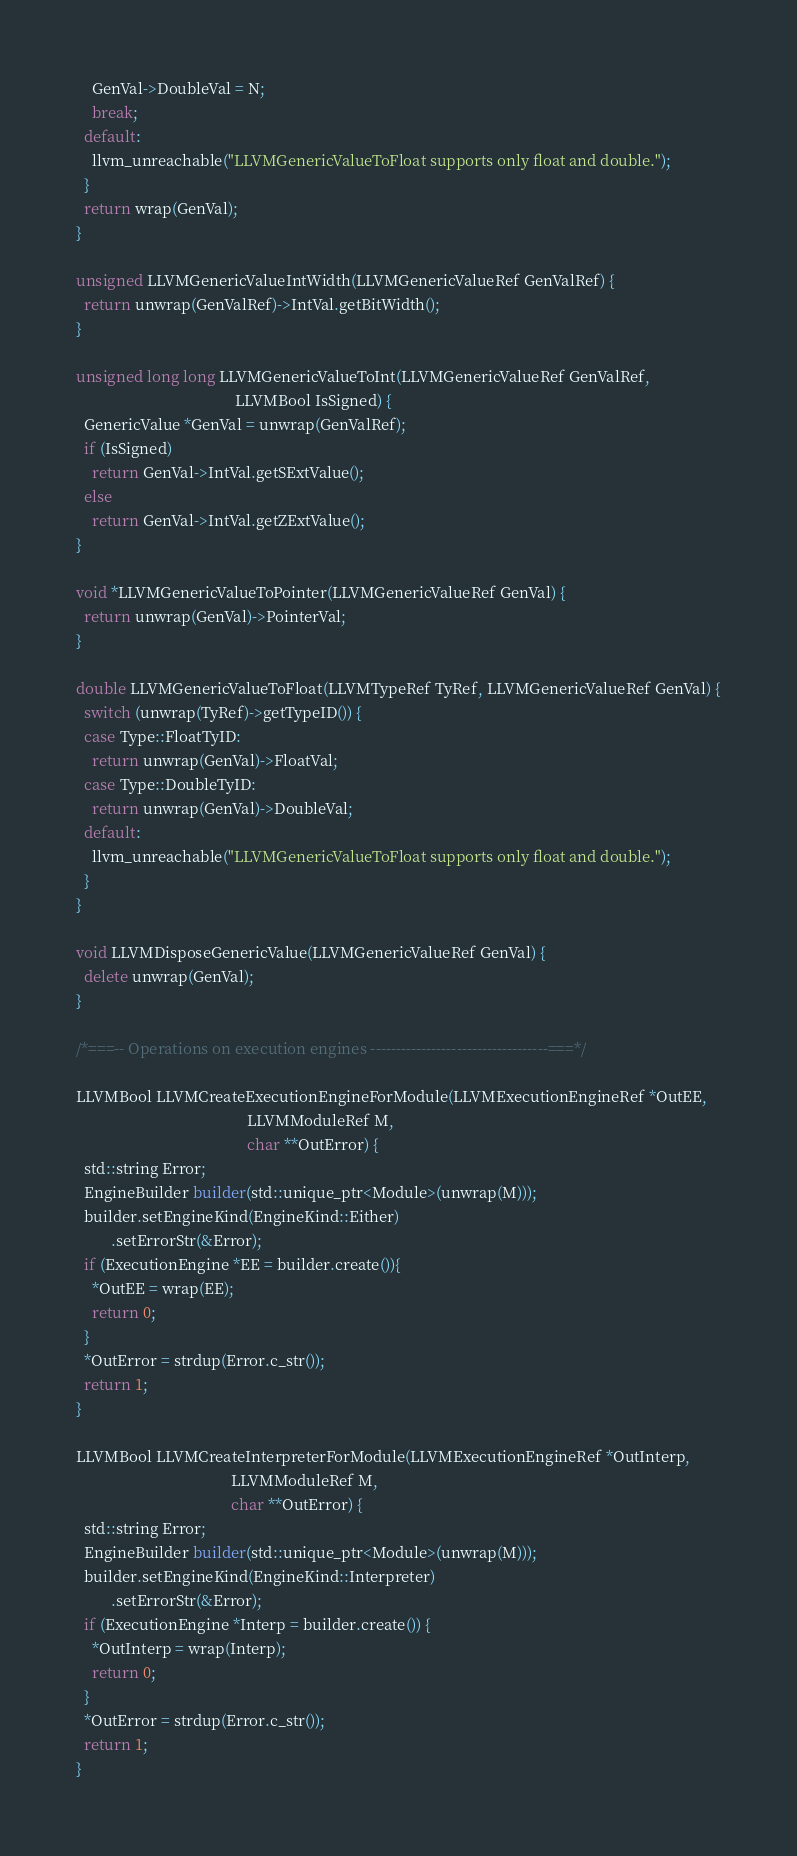<code> <loc_0><loc_0><loc_500><loc_500><_C++_>    GenVal->DoubleVal = N;
    break;
  default:
    llvm_unreachable("LLVMGenericValueToFloat supports only float and double.");
  }
  return wrap(GenVal);
}

unsigned LLVMGenericValueIntWidth(LLVMGenericValueRef GenValRef) {
  return unwrap(GenValRef)->IntVal.getBitWidth();
}

unsigned long long LLVMGenericValueToInt(LLVMGenericValueRef GenValRef,
                                         LLVMBool IsSigned) {
  GenericValue *GenVal = unwrap(GenValRef);
  if (IsSigned)
    return GenVal->IntVal.getSExtValue();
  else
    return GenVal->IntVal.getZExtValue();
}

void *LLVMGenericValueToPointer(LLVMGenericValueRef GenVal) {
  return unwrap(GenVal)->PointerVal;
}

double LLVMGenericValueToFloat(LLVMTypeRef TyRef, LLVMGenericValueRef GenVal) {
  switch (unwrap(TyRef)->getTypeID()) {
  case Type::FloatTyID:
    return unwrap(GenVal)->FloatVal;
  case Type::DoubleTyID:
    return unwrap(GenVal)->DoubleVal;
  default:
    llvm_unreachable("LLVMGenericValueToFloat supports only float and double.");
  }
}

void LLVMDisposeGenericValue(LLVMGenericValueRef GenVal) {
  delete unwrap(GenVal);
}

/*===-- Operations on execution engines -----------------------------------===*/

LLVMBool LLVMCreateExecutionEngineForModule(LLVMExecutionEngineRef *OutEE,
                                            LLVMModuleRef M,
                                            char **OutError) {
  std::string Error;
  EngineBuilder builder(std::unique_ptr<Module>(unwrap(M)));
  builder.setEngineKind(EngineKind::Either)
         .setErrorStr(&Error);
  if (ExecutionEngine *EE = builder.create()){
    *OutEE = wrap(EE);
    return 0;
  }
  *OutError = strdup(Error.c_str());
  return 1;
}

LLVMBool LLVMCreateInterpreterForModule(LLVMExecutionEngineRef *OutInterp,
                                        LLVMModuleRef M,
                                        char **OutError) {
  std::string Error;
  EngineBuilder builder(std::unique_ptr<Module>(unwrap(M)));
  builder.setEngineKind(EngineKind::Interpreter)
         .setErrorStr(&Error);
  if (ExecutionEngine *Interp = builder.create()) {
    *OutInterp = wrap(Interp);
    return 0;
  }
  *OutError = strdup(Error.c_str());
  return 1;
}
</code> 